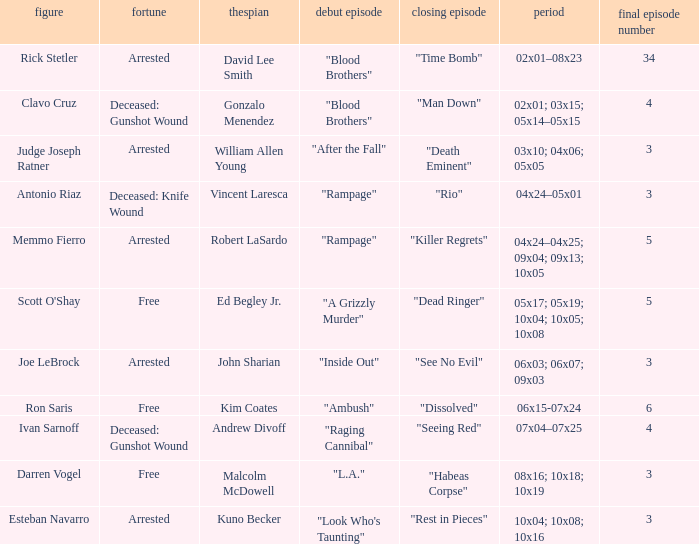What are all the actor where first episode is "ambush" Kim Coates. 